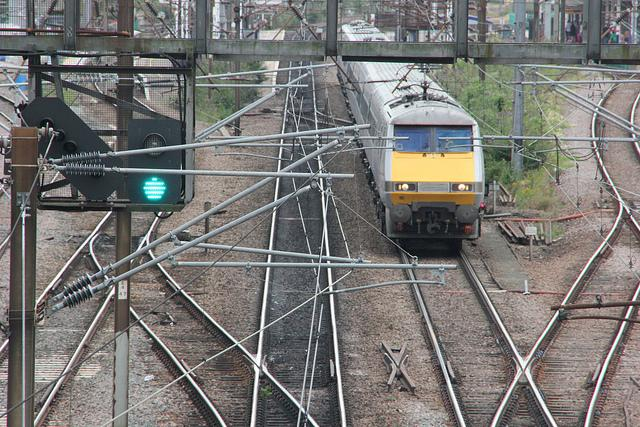The rightmost set of rails leads to which railway structure?

Choices:
A) workshop
B) depot
C) turntable
D) train station train station 